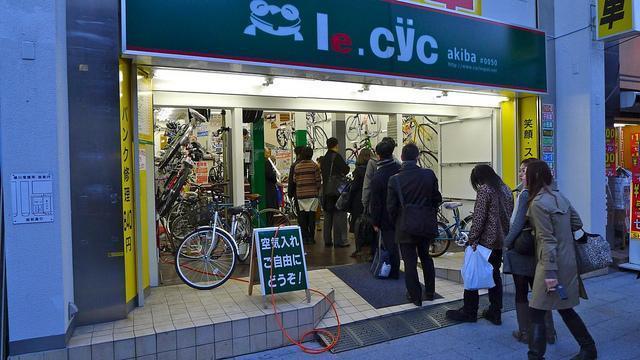How many people are there?
Give a very brief answer. 6. How many bicycles are there?
Give a very brief answer. 2. How many boats are there?
Give a very brief answer. 0. 